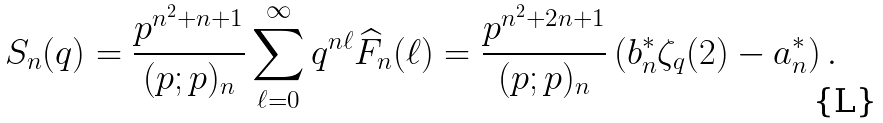<formula> <loc_0><loc_0><loc_500><loc_500>S _ { n } ( q ) = \frac { p ^ { n ^ { 2 } + n + 1 } } { ( p ; p ) _ { n } } \sum _ { \ell = 0 } ^ { \infty } q ^ { n \ell } \widehat { F } _ { n } ( \ell ) = \frac { p ^ { n ^ { 2 } + 2 n + 1 } } { ( p ; p ) _ { n } } \left ( b _ { n } ^ { * } \zeta _ { q } ( 2 ) - a _ { n } ^ { * } \right ) .</formula> 